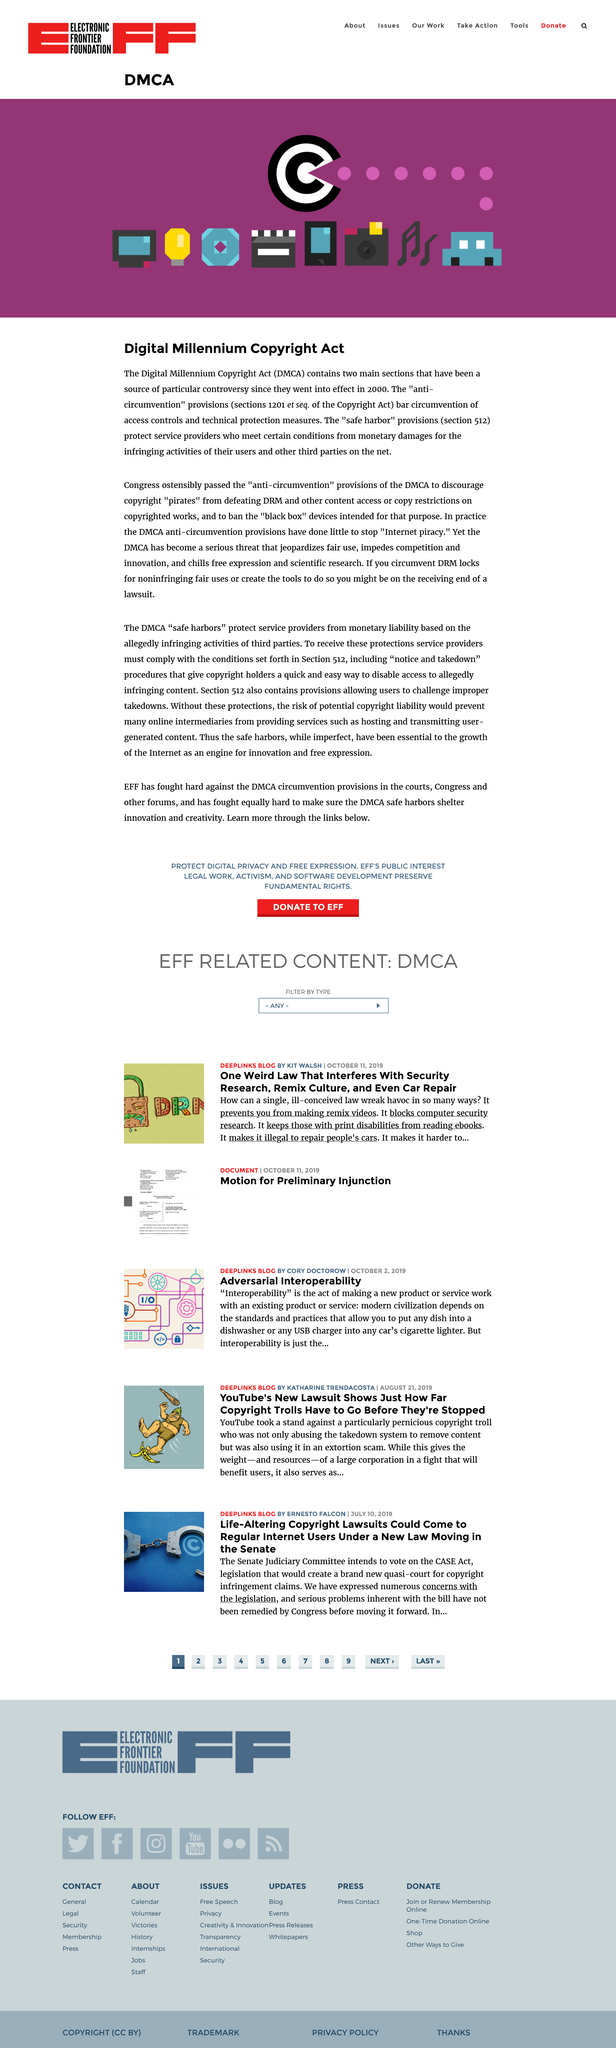Highlight a few significant elements in this photo. The controversial sections of the law came into effect in 2000. Two sections of the DMCA have been the subject of significant controversy. The Digital Millennium Copyright Act, commonly known as DMCA, is a federal law in the United States that provides legal protections for copyrighted works that are stored on the internet. 